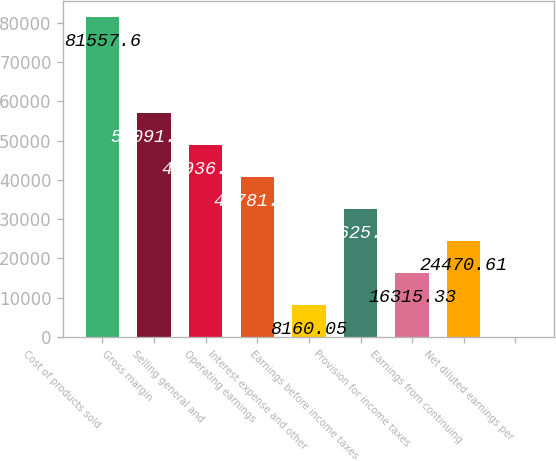Convert chart to OTSL. <chart><loc_0><loc_0><loc_500><loc_500><bar_chart><fcel>Cost of products sold<fcel>Gross margin<fcel>Selling general and<fcel>Operating earnings<fcel>Interest expense and other<fcel>Earnings before income taxes<fcel>Provision for income taxes<fcel>Earnings from continuing<fcel>Net diluted earnings per<nl><fcel>81557.6<fcel>57091.7<fcel>48936.4<fcel>40781.2<fcel>8160.05<fcel>32625.9<fcel>16315.3<fcel>24470.6<fcel>4.77<nl></chart> 